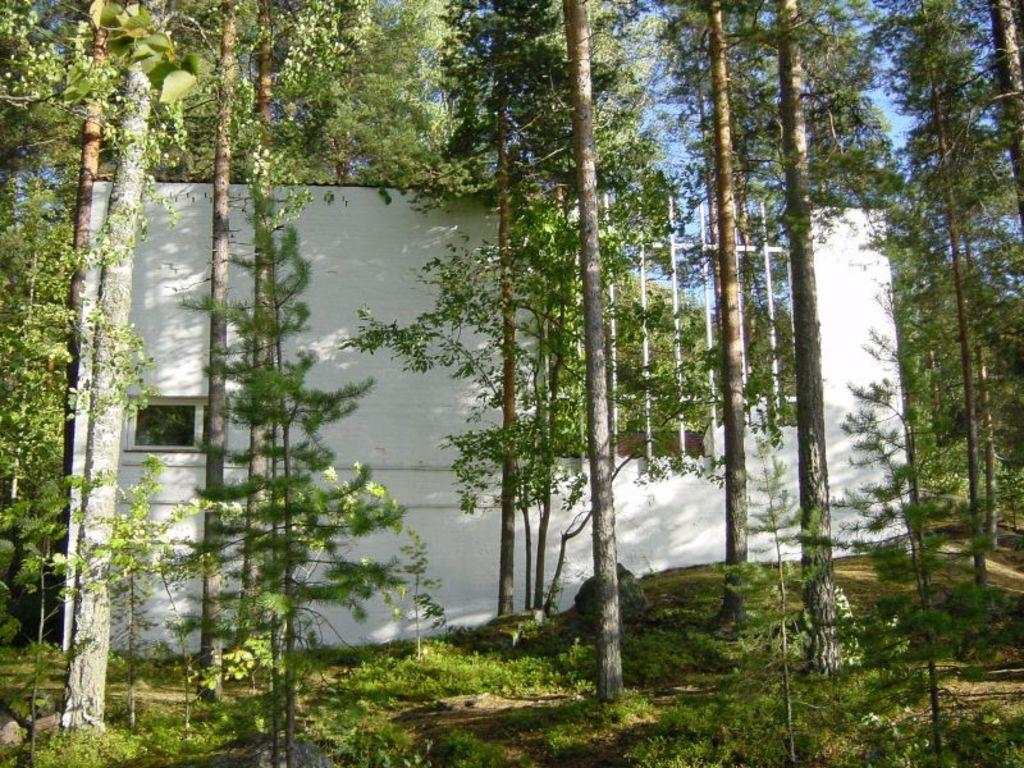What is located in the center of the image? There are trees in the center of the image. What can be seen in the background of the image? There is a building in the background of the image. What type of vegetation is at the bottom of the image? There is grass at the bottom of the image. Can you see any bones in the image? There are no bones present in the image. What type of vase is located near the trees in the image? There is no vase present in the image; it only features trees, a building, and grass. 